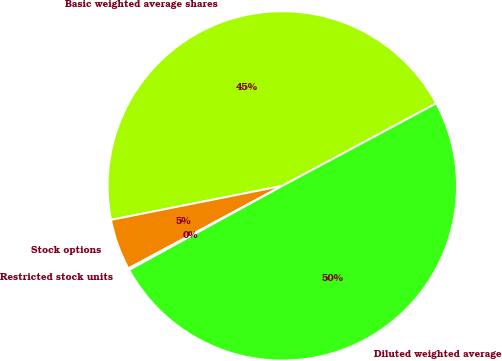<chart> <loc_0><loc_0><loc_500><loc_500><pie_chart><fcel>Basic weighted average shares<fcel>Stock options<fcel>Restricted stock units<fcel>Diluted weighted average<nl><fcel>45.28%<fcel>4.72%<fcel>0.15%<fcel>49.85%<nl></chart> 